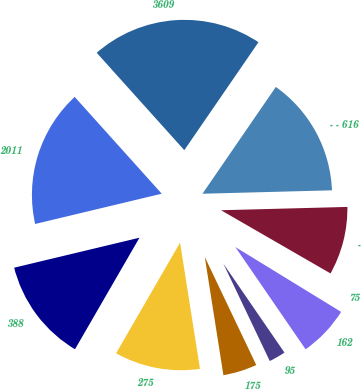Convert chart to OTSL. <chart><loc_0><loc_0><loc_500><loc_500><pie_chart><fcel>2011<fcel>388<fcel>275<fcel>175<fcel>95<fcel>162<fcel>75<fcel>-<fcel>- - 616<fcel>3609<nl><fcel>17.08%<fcel>12.92%<fcel>10.83%<fcel>4.59%<fcel>2.5%<fcel>6.67%<fcel>0.42%<fcel>8.75%<fcel>15.0%<fcel>21.24%<nl></chart> 